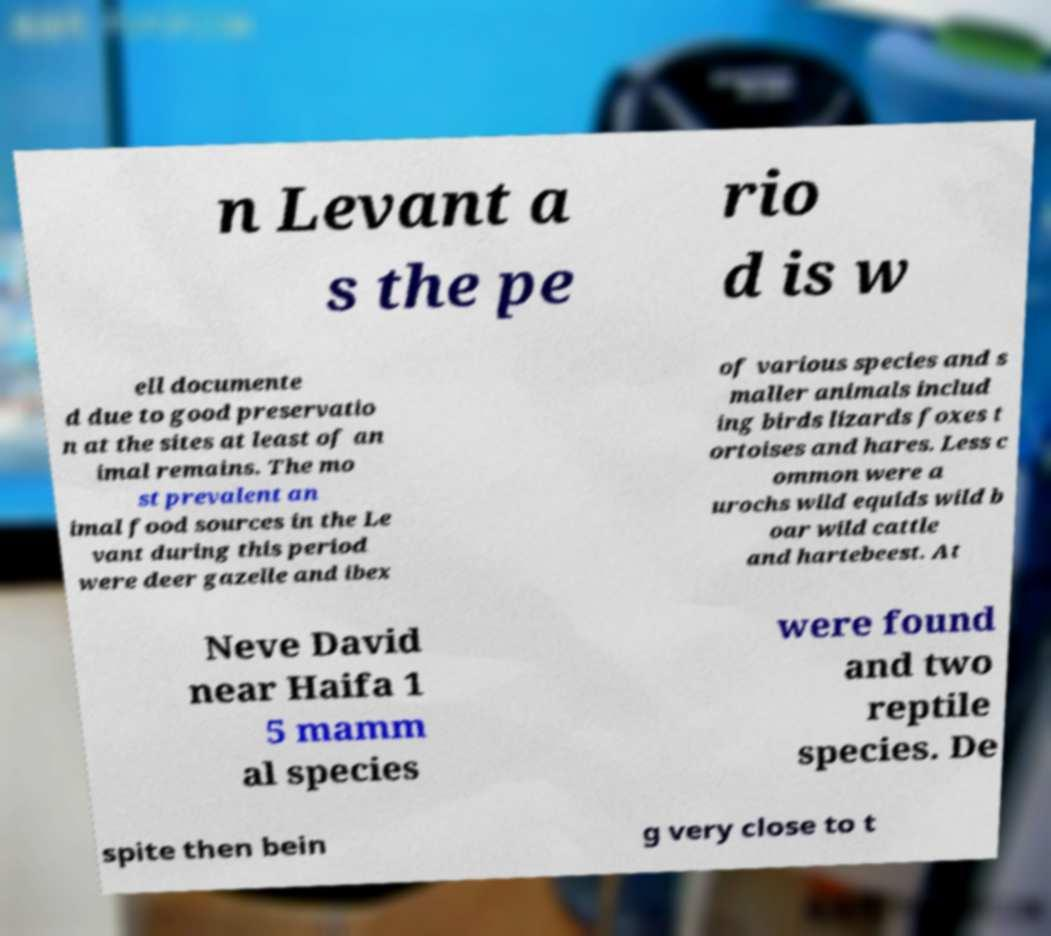Please identify and transcribe the text found in this image. n Levant a s the pe rio d is w ell documente d due to good preservatio n at the sites at least of an imal remains. The mo st prevalent an imal food sources in the Le vant during this period were deer gazelle and ibex of various species and s maller animals includ ing birds lizards foxes t ortoises and hares. Less c ommon were a urochs wild equids wild b oar wild cattle and hartebeest. At Neve David near Haifa 1 5 mamm al species were found and two reptile species. De spite then bein g very close to t 